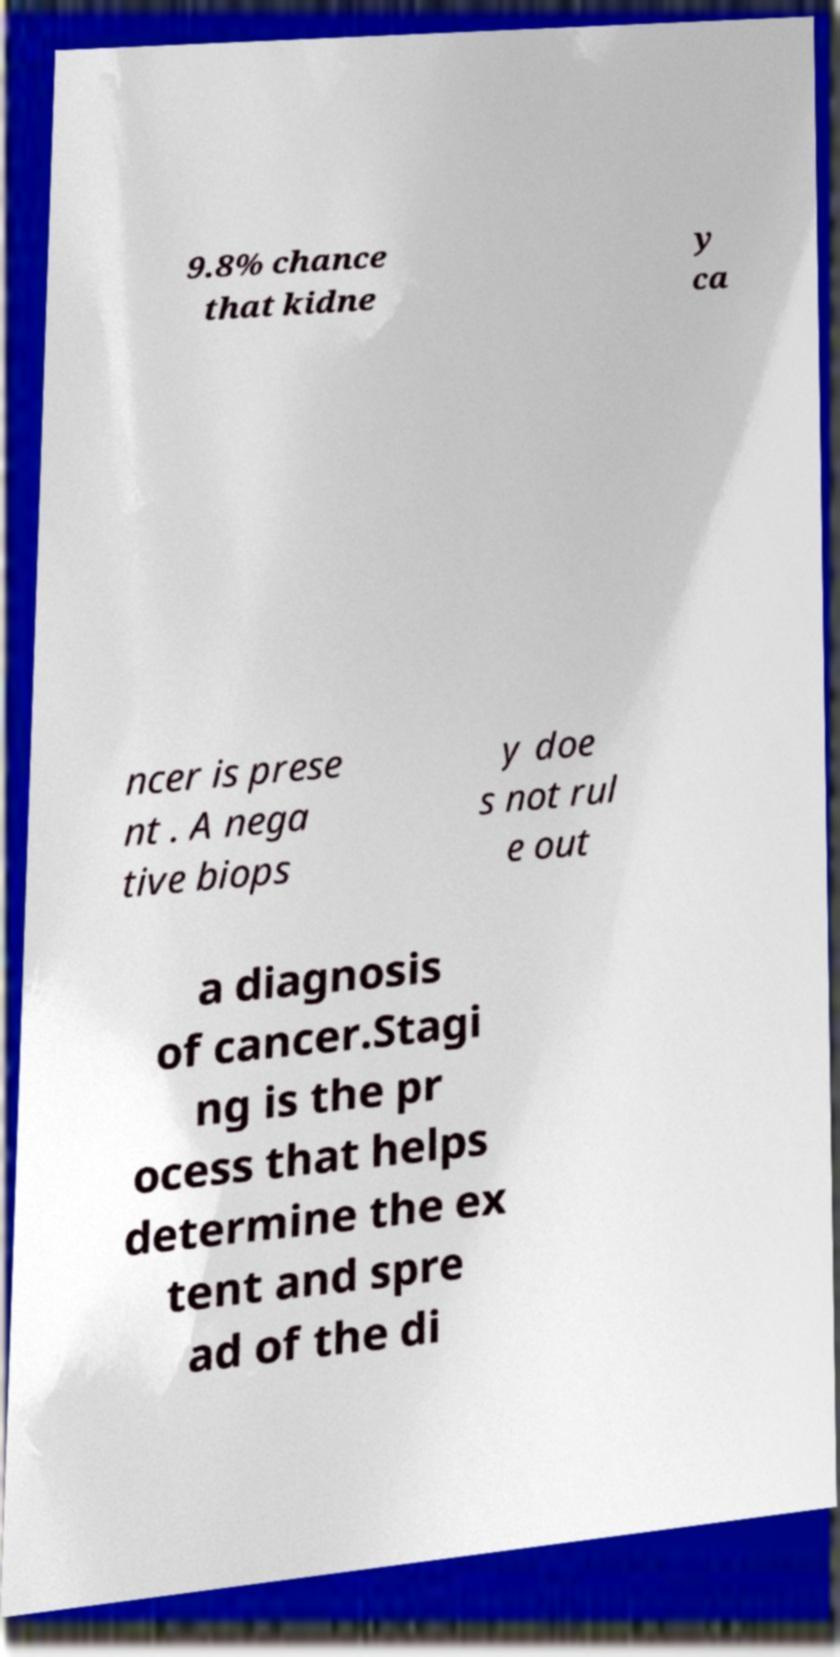Could you extract and type out the text from this image? 9.8% chance that kidne y ca ncer is prese nt . A nega tive biops y doe s not rul e out a diagnosis of cancer.Stagi ng is the pr ocess that helps determine the ex tent and spre ad of the di 